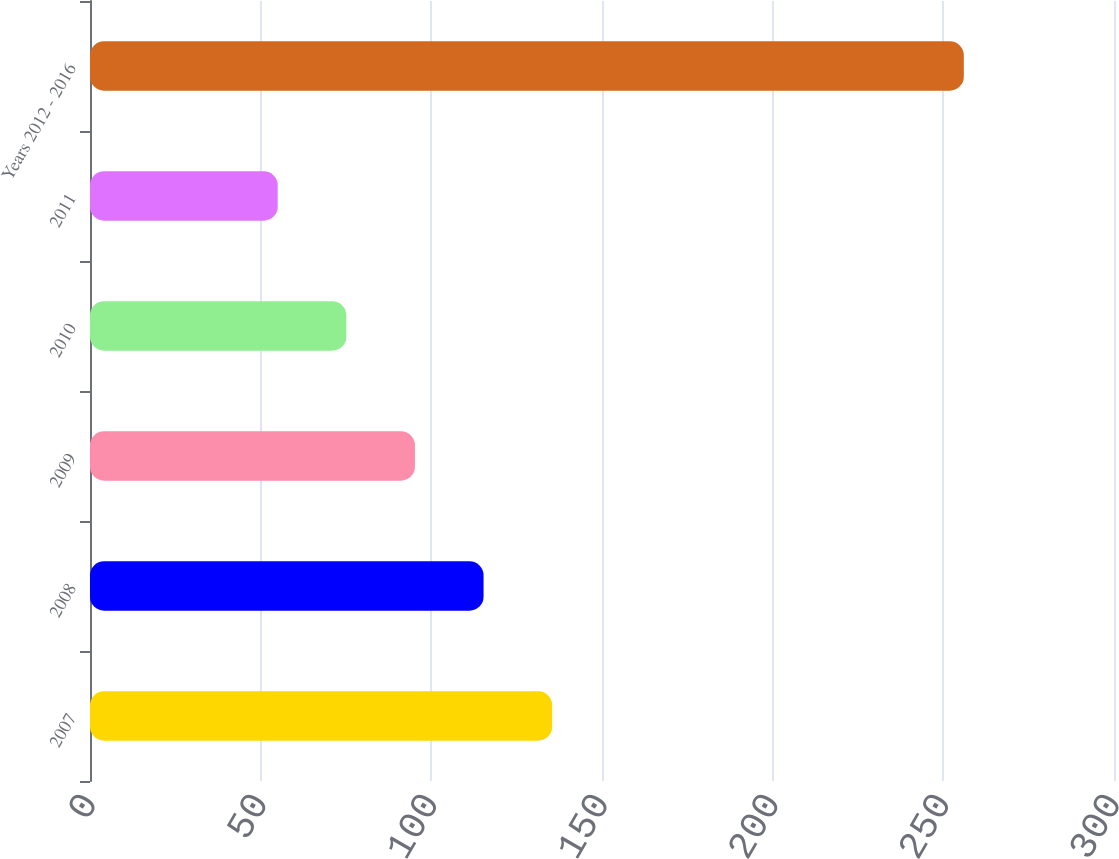Convert chart. <chart><loc_0><loc_0><loc_500><loc_500><bar_chart><fcel>2007<fcel>2008<fcel>2009<fcel>2010<fcel>2011<fcel>Years 2012 - 2016<nl><fcel>135.4<fcel>115.3<fcel>95.2<fcel>75.1<fcel>55<fcel>256<nl></chart> 